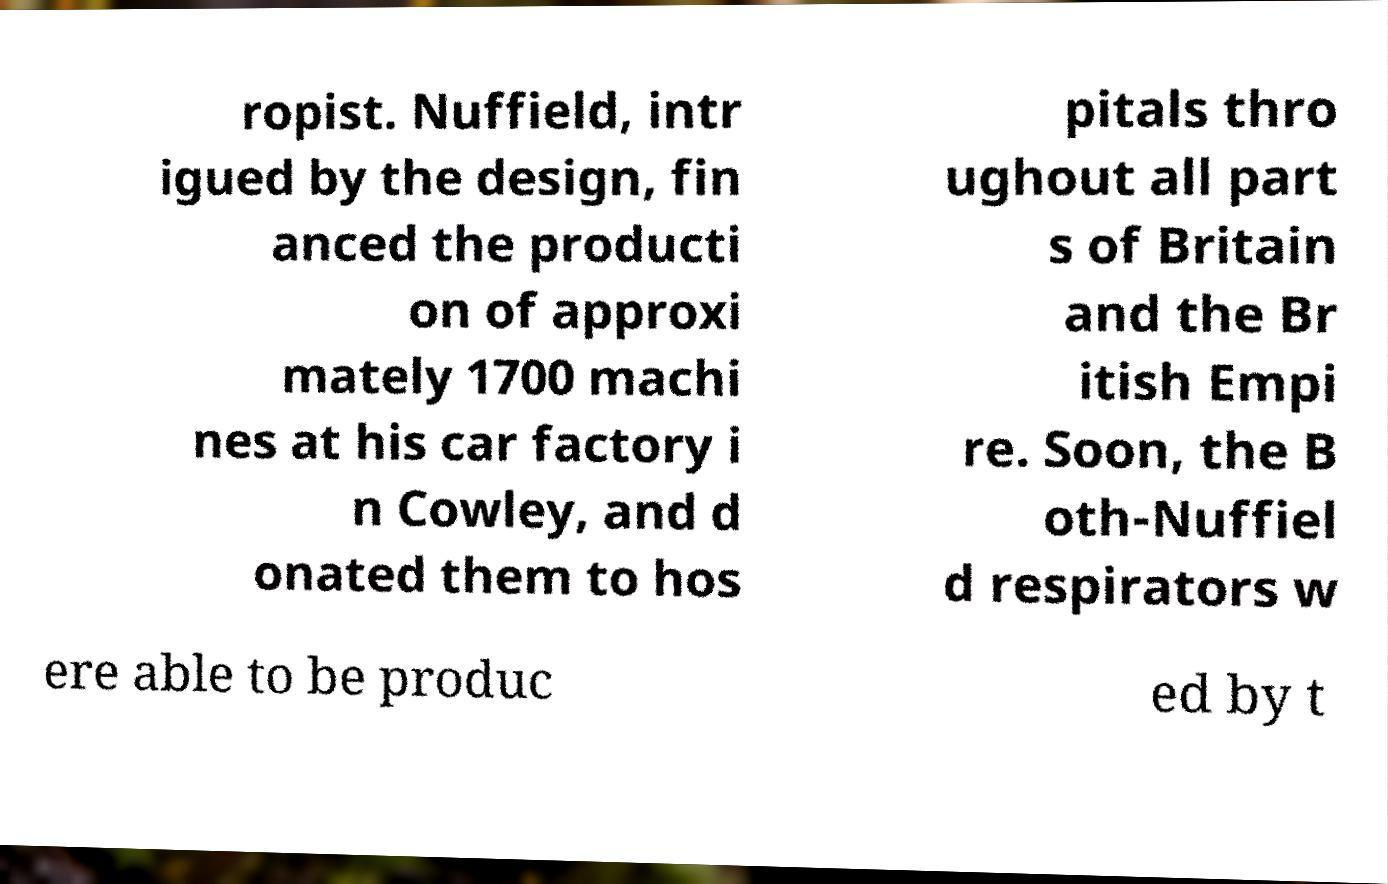For documentation purposes, I need the text within this image transcribed. Could you provide that? ropist. Nuffield, intr igued by the design, fin anced the producti on of approxi mately 1700 machi nes at his car factory i n Cowley, and d onated them to hos pitals thro ughout all part s of Britain and the Br itish Empi re. Soon, the B oth-Nuffiel d respirators w ere able to be produc ed by t 